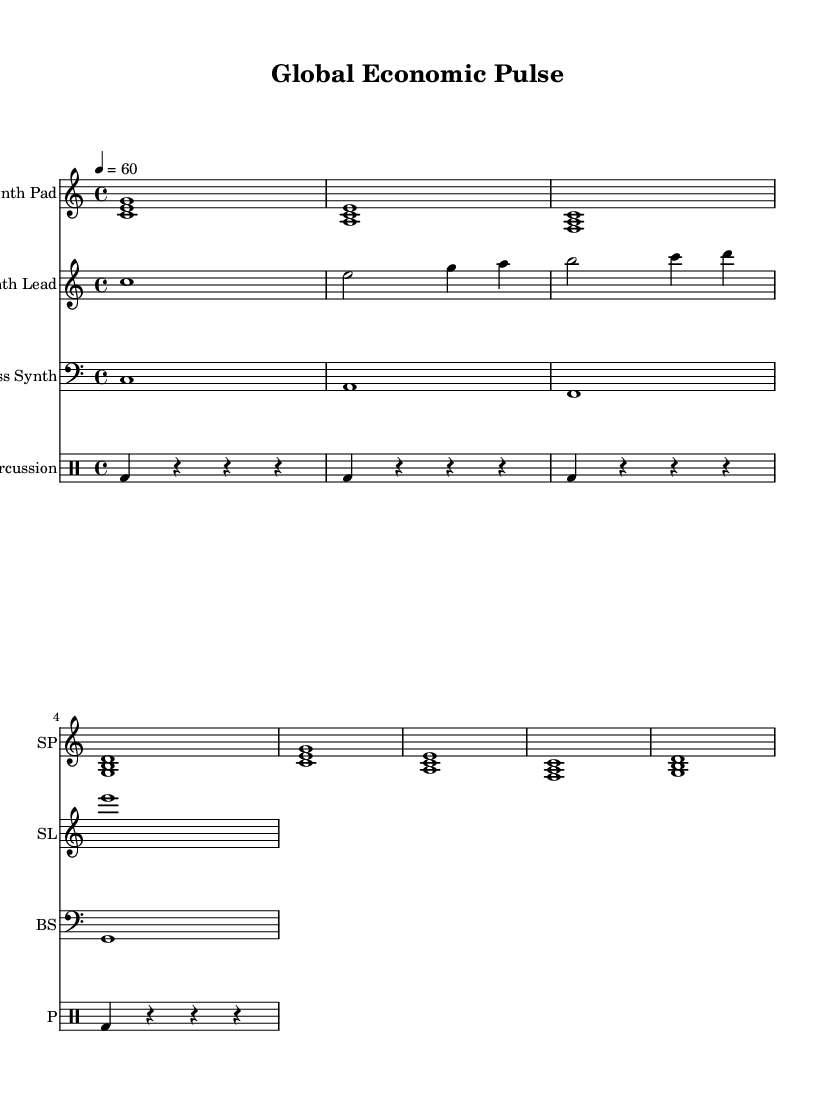What is the key signature of this music? The key signature is C major, which is indicated by no sharps or flats in the music.
Answer: C major What is the time signature of this music? The time signature is 4/4, as represented at the beginning of the score, indicating four beats per measure.
Answer: 4/4 What is the tempo marking of this piece? The tempo is marked as 4 = 60, meaning the quarter note gets a beat of 60 beats per minute.
Answer: 60 How many measures are in the Synth Pad section? The Synth Pad section consists of 8 measures as indicated by the repetition of two sets of four measures.
Answer: 8 What instruments are used in this score? The instruments used are Synth Pad, Synth Lead, Bass Synth, and Percussion, as labeled at the beginning of each staff.
Answer: Synth Pad, Synth Lead, Bass Synth, Percussion What type of drum pattern is utilized? The drum pattern consists of bass drum notes with rests interspersed, creating a simple rhythmic foundation.
Answer: Bass drum pattern with rests Which notes are played in the Synth Lead during the first measure? In the first measure of Synth Lead, the note played is C, as seen in the notation.
Answer: C 